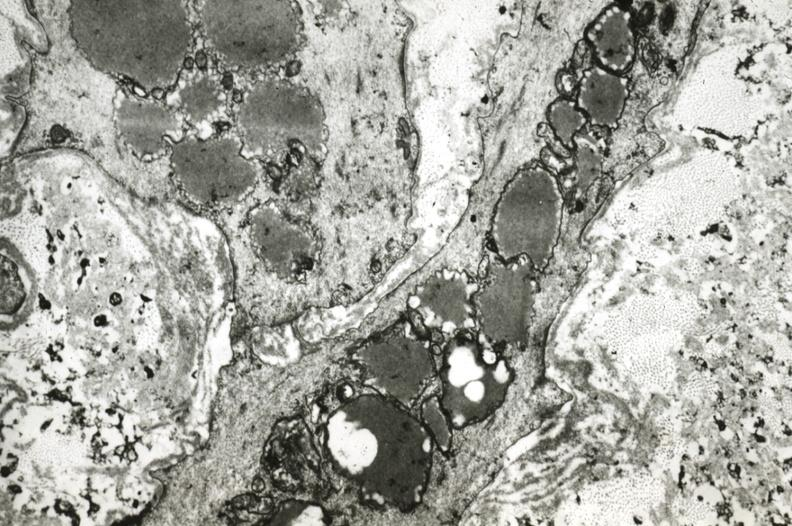how does this image show intimal smooth muscle cells?
Answer the question using a single word or phrase. With lipid in cytoplasm and precipitated lipid in interstitial space 